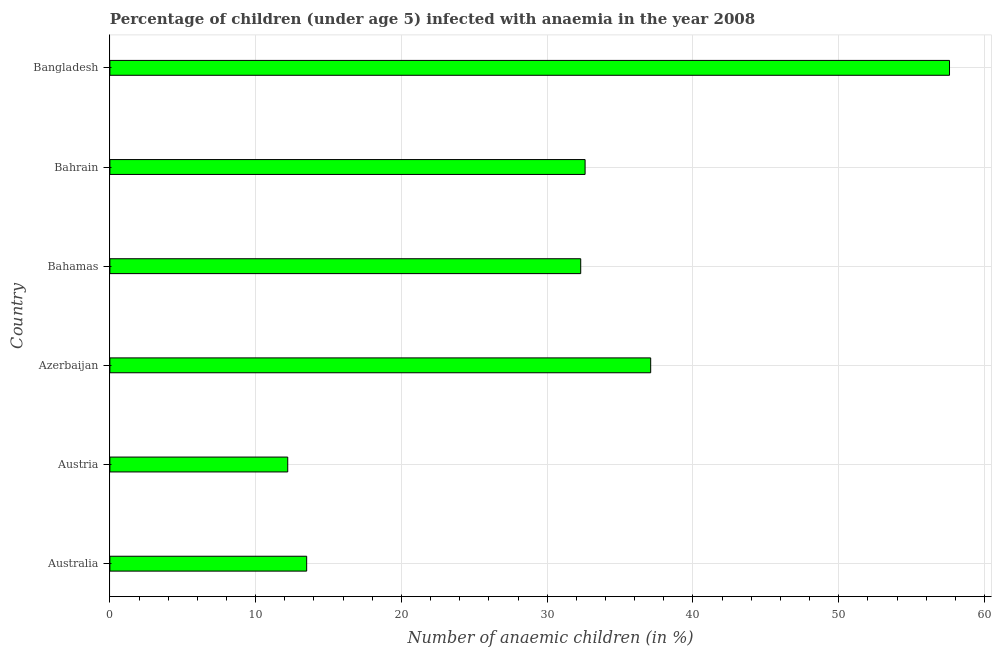What is the title of the graph?
Provide a succinct answer. Percentage of children (under age 5) infected with anaemia in the year 2008. What is the label or title of the X-axis?
Provide a short and direct response. Number of anaemic children (in %). What is the label or title of the Y-axis?
Your answer should be compact. Country. Across all countries, what is the maximum number of anaemic children?
Keep it short and to the point. 57.6. Across all countries, what is the minimum number of anaemic children?
Your answer should be very brief. 12.2. In which country was the number of anaemic children maximum?
Offer a terse response. Bangladesh. In which country was the number of anaemic children minimum?
Provide a short and direct response. Austria. What is the sum of the number of anaemic children?
Your answer should be compact. 185.3. What is the difference between the number of anaemic children in Australia and Bangladesh?
Provide a succinct answer. -44.1. What is the average number of anaemic children per country?
Provide a short and direct response. 30.88. What is the median number of anaemic children?
Your answer should be compact. 32.45. What is the ratio of the number of anaemic children in Azerbaijan to that in Bangladesh?
Ensure brevity in your answer.  0.64. Is the number of anaemic children in Bahamas less than that in Bahrain?
Your response must be concise. Yes. What is the difference between the highest and the lowest number of anaemic children?
Provide a short and direct response. 45.4. How many countries are there in the graph?
Ensure brevity in your answer.  6. What is the difference between two consecutive major ticks on the X-axis?
Ensure brevity in your answer.  10. Are the values on the major ticks of X-axis written in scientific E-notation?
Keep it short and to the point. No. What is the Number of anaemic children (in %) of Azerbaijan?
Keep it short and to the point. 37.1. What is the Number of anaemic children (in %) of Bahamas?
Your response must be concise. 32.3. What is the Number of anaemic children (in %) in Bahrain?
Ensure brevity in your answer.  32.6. What is the Number of anaemic children (in %) in Bangladesh?
Ensure brevity in your answer.  57.6. What is the difference between the Number of anaemic children (in %) in Australia and Azerbaijan?
Keep it short and to the point. -23.6. What is the difference between the Number of anaemic children (in %) in Australia and Bahamas?
Give a very brief answer. -18.8. What is the difference between the Number of anaemic children (in %) in Australia and Bahrain?
Your answer should be very brief. -19.1. What is the difference between the Number of anaemic children (in %) in Australia and Bangladesh?
Give a very brief answer. -44.1. What is the difference between the Number of anaemic children (in %) in Austria and Azerbaijan?
Your answer should be compact. -24.9. What is the difference between the Number of anaemic children (in %) in Austria and Bahamas?
Give a very brief answer. -20.1. What is the difference between the Number of anaemic children (in %) in Austria and Bahrain?
Offer a terse response. -20.4. What is the difference between the Number of anaemic children (in %) in Austria and Bangladesh?
Give a very brief answer. -45.4. What is the difference between the Number of anaemic children (in %) in Azerbaijan and Bahamas?
Make the answer very short. 4.8. What is the difference between the Number of anaemic children (in %) in Azerbaijan and Bangladesh?
Ensure brevity in your answer.  -20.5. What is the difference between the Number of anaemic children (in %) in Bahamas and Bangladesh?
Offer a terse response. -25.3. What is the ratio of the Number of anaemic children (in %) in Australia to that in Austria?
Ensure brevity in your answer.  1.11. What is the ratio of the Number of anaemic children (in %) in Australia to that in Azerbaijan?
Offer a terse response. 0.36. What is the ratio of the Number of anaemic children (in %) in Australia to that in Bahamas?
Keep it short and to the point. 0.42. What is the ratio of the Number of anaemic children (in %) in Australia to that in Bahrain?
Provide a short and direct response. 0.41. What is the ratio of the Number of anaemic children (in %) in Australia to that in Bangladesh?
Offer a terse response. 0.23. What is the ratio of the Number of anaemic children (in %) in Austria to that in Azerbaijan?
Your answer should be compact. 0.33. What is the ratio of the Number of anaemic children (in %) in Austria to that in Bahamas?
Your answer should be very brief. 0.38. What is the ratio of the Number of anaemic children (in %) in Austria to that in Bahrain?
Your answer should be compact. 0.37. What is the ratio of the Number of anaemic children (in %) in Austria to that in Bangladesh?
Provide a short and direct response. 0.21. What is the ratio of the Number of anaemic children (in %) in Azerbaijan to that in Bahamas?
Provide a short and direct response. 1.15. What is the ratio of the Number of anaemic children (in %) in Azerbaijan to that in Bahrain?
Provide a succinct answer. 1.14. What is the ratio of the Number of anaemic children (in %) in Azerbaijan to that in Bangladesh?
Give a very brief answer. 0.64. What is the ratio of the Number of anaemic children (in %) in Bahamas to that in Bangladesh?
Provide a short and direct response. 0.56. What is the ratio of the Number of anaemic children (in %) in Bahrain to that in Bangladesh?
Make the answer very short. 0.57. 